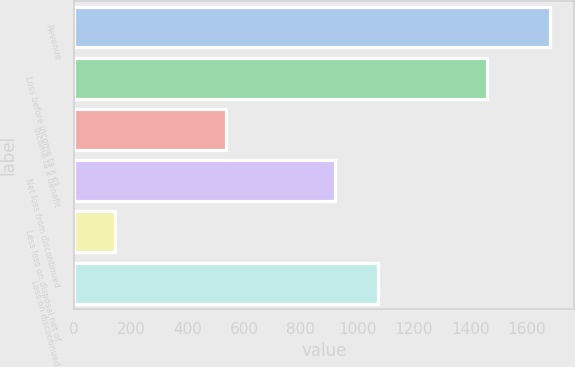Convert chart. <chart><loc_0><loc_0><loc_500><loc_500><bar_chart><fcel>Revenue<fcel>Loss before income ta x es<fcel>Income ta x benefit<fcel>Net loss from discontinued<fcel>Less loss on disposal net of<fcel>Loss on discontinued<nl><fcel>1680<fcel>1457<fcel>536<fcel>921<fcel>144<fcel>1074.6<nl></chart> 